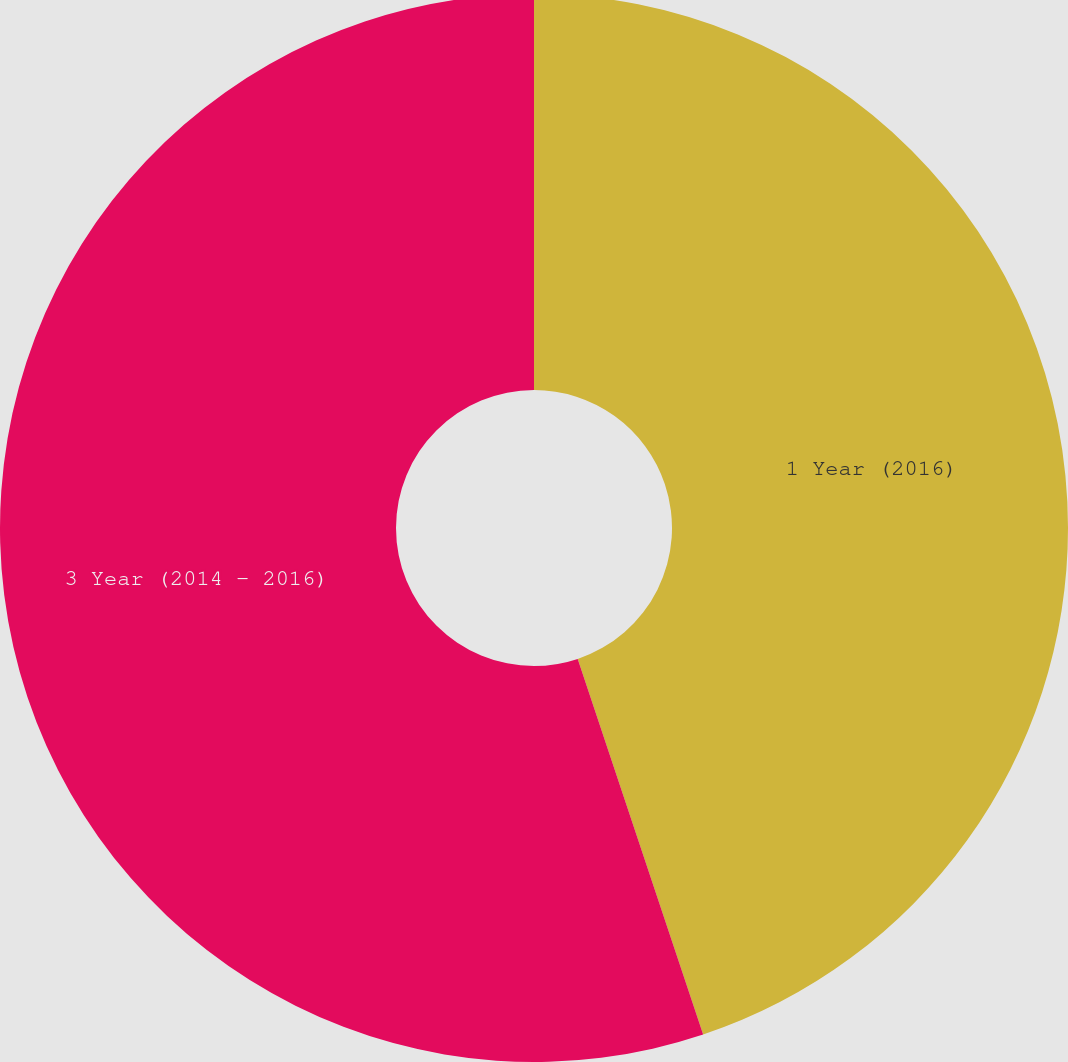Convert chart to OTSL. <chart><loc_0><loc_0><loc_500><loc_500><pie_chart><fcel>1 Year (2016)<fcel>3 Year (2014 - 2016)<nl><fcel>44.87%<fcel>55.13%<nl></chart> 